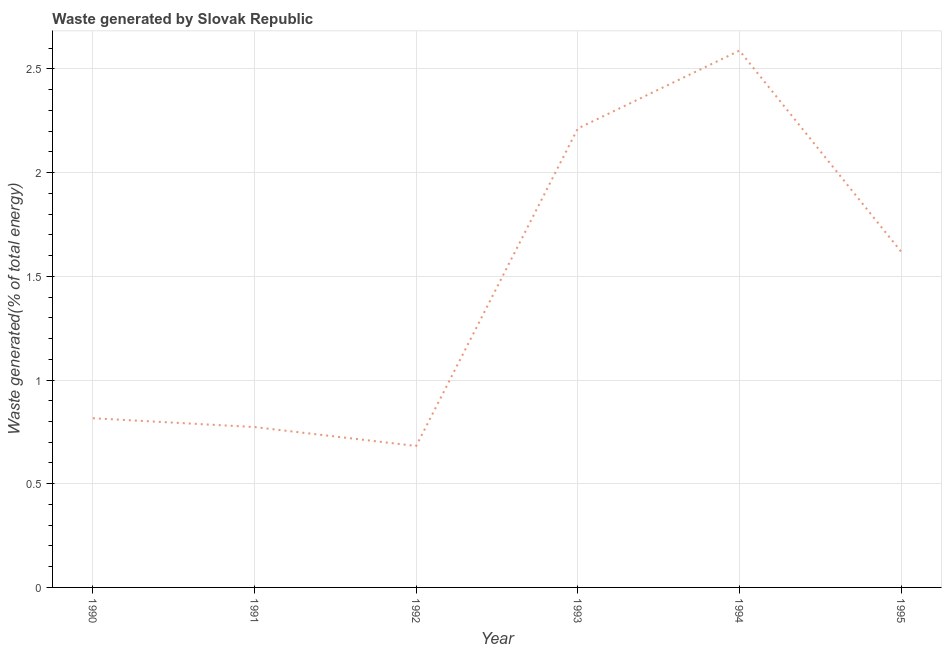What is the amount of waste generated in 1994?
Your answer should be compact. 2.59. Across all years, what is the maximum amount of waste generated?
Keep it short and to the point. 2.59. Across all years, what is the minimum amount of waste generated?
Provide a short and direct response. 0.68. In which year was the amount of waste generated maximum?
Ensure brevity in your answer.  1994. In which year was the amount of waste generated minimum?
Your answer should be very brief. 1992. What is the sum of the amount of waste generated?
Your answer should be very brief. 8.69. What is the difference between the amount of waste generated in 1990 and 1995?
Your answer should be compact. -0.8. What is the average amount of waste generated per year?
Your answer should be compact. 1.45. What is the median amount of waste generated?
Offer a very short reply. 1.22. In how many years, is the amount of waste generated greater than 0.5 %?
Offer a very short reply. 6. Do a majority of the years between 1994 and 1992 (inclusive) have amount of waste generated greater than 0.4 %?
Make the answer very short. No. What is the ratio of the amount of waste generated in 1990 to that in 1994?
Keep it short and to the point. 0.32. What is the difference between the highest and the second highest amount of waste generated?
Provide a short and direct response. 0.38. What is the difference between the highest and the lowest amount of waste generated?
Ensure brevity in your answer.  1.91. In how many years, is the amount of waste generated greater than the average amount of waste generated taken over all years?
Provide a succinct answer. 3. Does the amount of waste generated monotonically increase over the years?
Make the answer very short. No. What is the difference between two consecutive major ticks on the Y-axis?
Provide a short and direct response. 0.5. Does the graph contain any zero values?
Offer a terse response. No. Does the graph contain grids?
Make the answer very short. Yes. What is the title of the graph?
Offer a very short reply. Waste generated by Slovak Republic. What is the label or title of the Y-axis?
Your answer should be very brief. Waste generated(% of total energy). What is the Waste generated(% of total energy) in 1990?
Provide a succinct answer. 0.82. What is the Waste generated(% of total energy) in 1991?
Your response must be concise. 0.77. What is the Waste generated(% of total energy) in 1992?
Your answer should be very brief. 0.68. What is the Waste generated(% of total energy) in 1993?
Give a very brief answer. 2.21. What is the Waste generated(% of total energy) of 1994?
Ensure brevity in your answer.  2.59. What is the Waste generated(% of total energy) in 1995?
Keep it short and to the point. 1.62. What is the difference between the Waste generated(% of total energy) in 1990 and 1991?
Your response must be concise. 0.04. What is the difference between the Waste generated(% of total energy) in 1990 and 1992?
Provide a short and direct response. 0.13. What is the difference between the Waste generated(% of total energy) in 1990 and 1993?
Provide a succinct answer. -1.4. What is the difference between the Waste generated(% of total energy) in 1990 and 1994?
Your response must be concise. -1.77. What is the difference between the Waste generated(% of total energy) in 1990 and 1995?
Offer a very short reply. -0.8. What is the difference between the Waste generated(% of total energy) in 1991 and 1992?
Give a very brief answer. 0.09. What is the difference between the Waste generated(% of total energy) in 1991 and 1993?
Offer a very short reply. -1.44. What is the difference between the Waste generated(% of total energy) in 1991 and 1994?
Keep it short and to the point. -1.82. What is the difference between the Waste generated(% of total energy) in 1991 and 1995?
Give a very brief answer. -0.85. What is the difference between the Waste generated(% of total energy) in 1992 and 1993?
Your response must be concise. -1.53. What is the difference between the Waste generated(% of total energy) in 1992 and 1994?
Give a very brief answer. -1.91. What is the difference between the Waste generated(% of total energy) in 1992 and 1995?
Make the answer very short. -0.94. What is the difference between the Waste generated(% of total energy) in 1993 and 1994?
Ensure brevity in your answer.  -0.38. What is the difference between the Waste generated(% of total energy) in 1993 and 1995?
Offer a terse response. 0.59. What is the difference between the Waste generated(% of total energy) in 1994 and 1995?
Offer a very short reply. 0.97. What is the ratio of the Waste generated(% of total energy) in 1990 to that in 1991?
Provide a succinct answer. 1.05. What is the ratio of the Waste generated(% of total energy) in 1990 to that in 1992?
Ensure brevity in your answer.  1.2. What is the ratio of the Waste generated(% of total energy) in 1990 to that in 1993?
Make the answer very short. 0.37. What is the ratio of the Waste generated(% of total energy) in 1990 to that in 1994?
Give a very brief answer. 0.32. What is the ratio of the Waste generated(% of total energy) in 1990 to that in 1995?
Offer a very short reply. 0.5. What is the ratio of the Waste generated(% of total energy) in 1991 to that in 1992?
Provide a succinct answer. 1.13. What is the ratio of the Waste generated(% of total energy) in 1991 to that in 1993?
Provide a succinct answer. 0.35. What is the ratio of the Waste generated(% of total energy) in 1991 to that in 1994?
Ensure brevity in your answer.  0.3. What is the ratio of the Waste generated(% of total energy) in 1991 to that in 1995?
Offer a very short reply. 0.48. What is the ratio of the Waste generated(% of total energy) in 1992 to that in 1993?
Your answer should be very brief. 0.31. What is the ratio of the Waste generated(% of total energy) in 1992 to that in 1994?
Your answer should be very brief. 0.26. What is the ratio of the Waste generated(% of total energy) in 1992 to that in 1995?
Make the answer very short. 0.42. What is the ratio of the Waste generated(% of total energy) in 1993 to that in 1994?
Provide a succinct answer. 0.85. What is the ratio of the Waste generated(% of total energy) in 1993 to that in 1995?
Your response must be concise. 1.37. What is the ratio of the Waste generated(% of total energy) in 1994 to that in 1995?
Your answer should be compact. 1.6. 